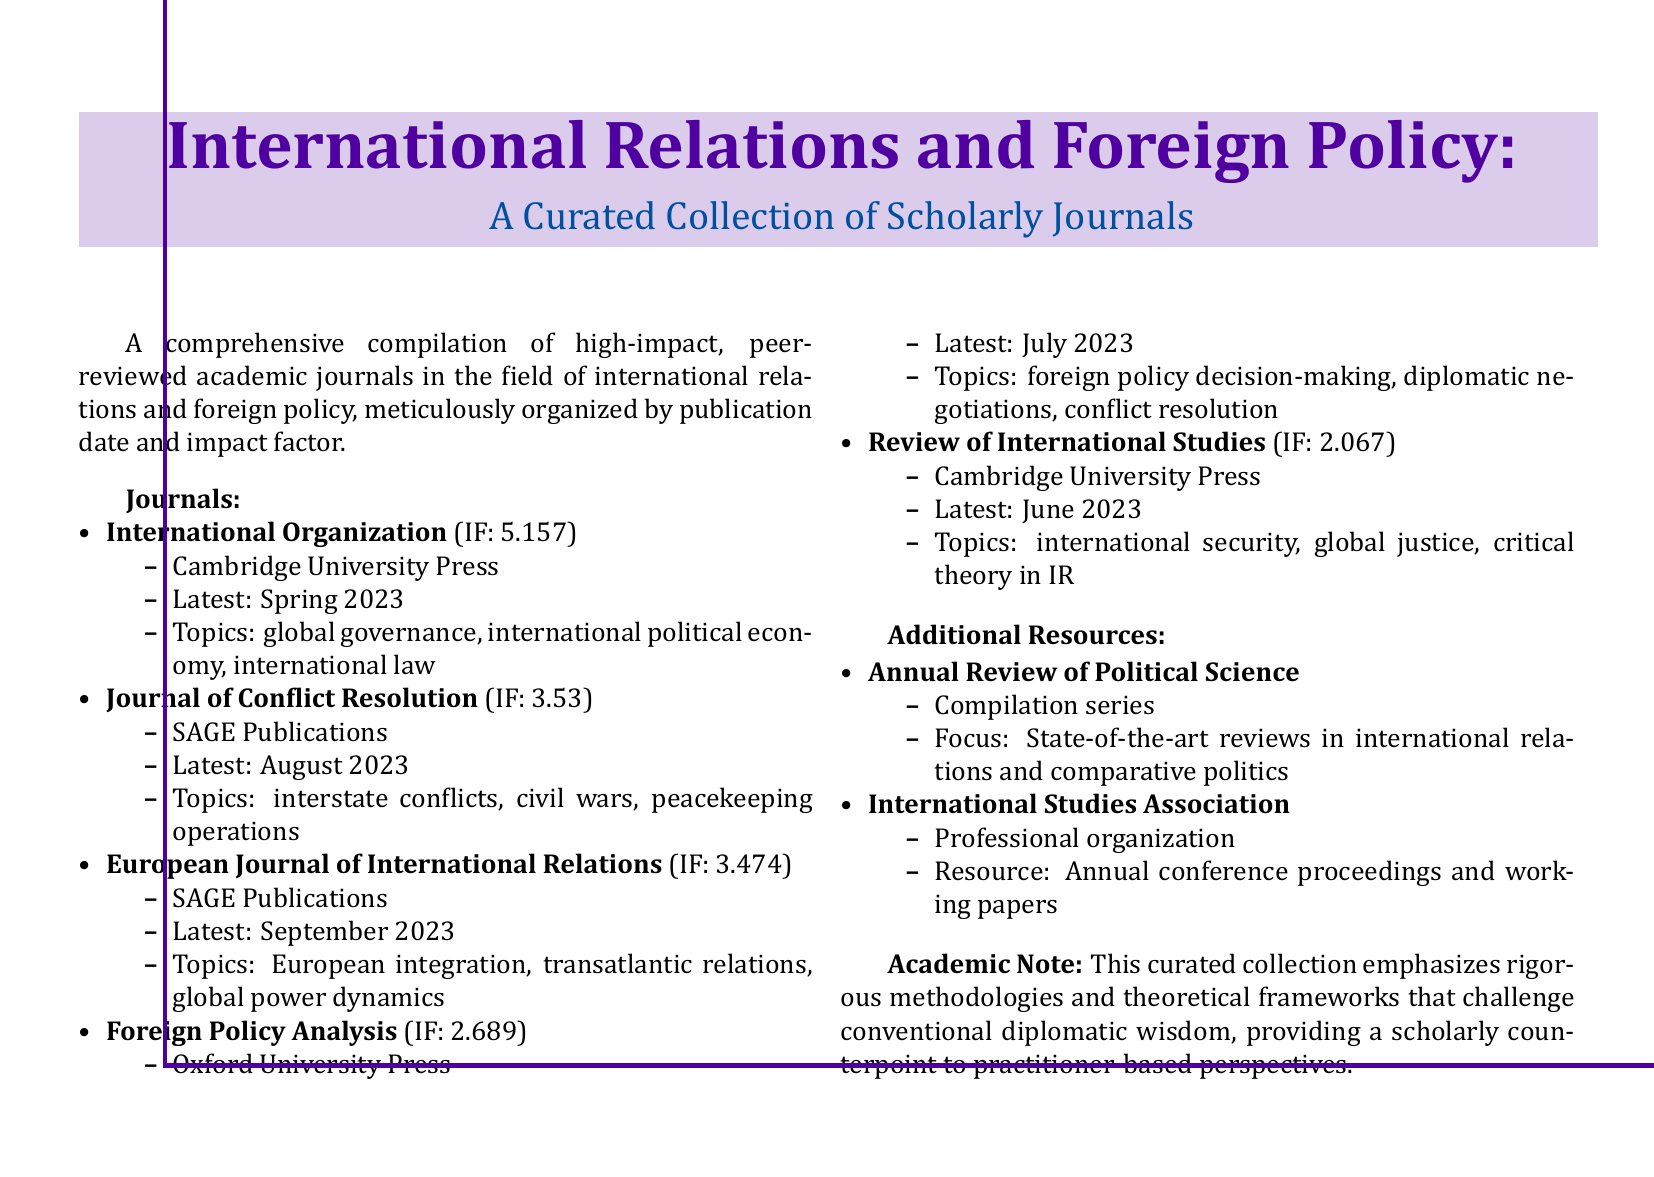What is the impact factor of International Organization? The impact factor is listed directly next to the journal name in the document.
Answer: 5.157 When was the latest issue of the Journal of Conflict Resolution published? The latest issue date is provided in the document under the journal information.
Answer: August 2023 What topics are covered in the European Journal of International Relations? The topics are listed in the document directly under the journal's name.
Answer: European integration, transatlantic relations, global power dynamics Which publisher produces the Foreign Policy Analysis journal? The publisher's name is mentioned right below the impact factor for each journal.
Answer: Oxford University Press What is the lowest impact factor among the listed journals? The impact factors are mentioned, and the lowest one needs to be identified by comparison.
Answer: 2.067 How many journals are listed in the document? The total number of journals is indicated by the list format in the document.
Answer: 5 What additional resource focuses on state-of-the-art reviews in international relations? The resource is explicitly mentioned under the Additional Resources section in the document.
Answer: Annual Review of Political Science Which organization offers annual conference proceedings and working papers? This information is provided under the Additional Resources section, related to a professional organization.
Answer: International Studies Association What does the academic note emphasize about the collection? The note at the end summarizes the overarching theme of the collection.
Answer: Rigorous methodologies and theoretical frameworks 